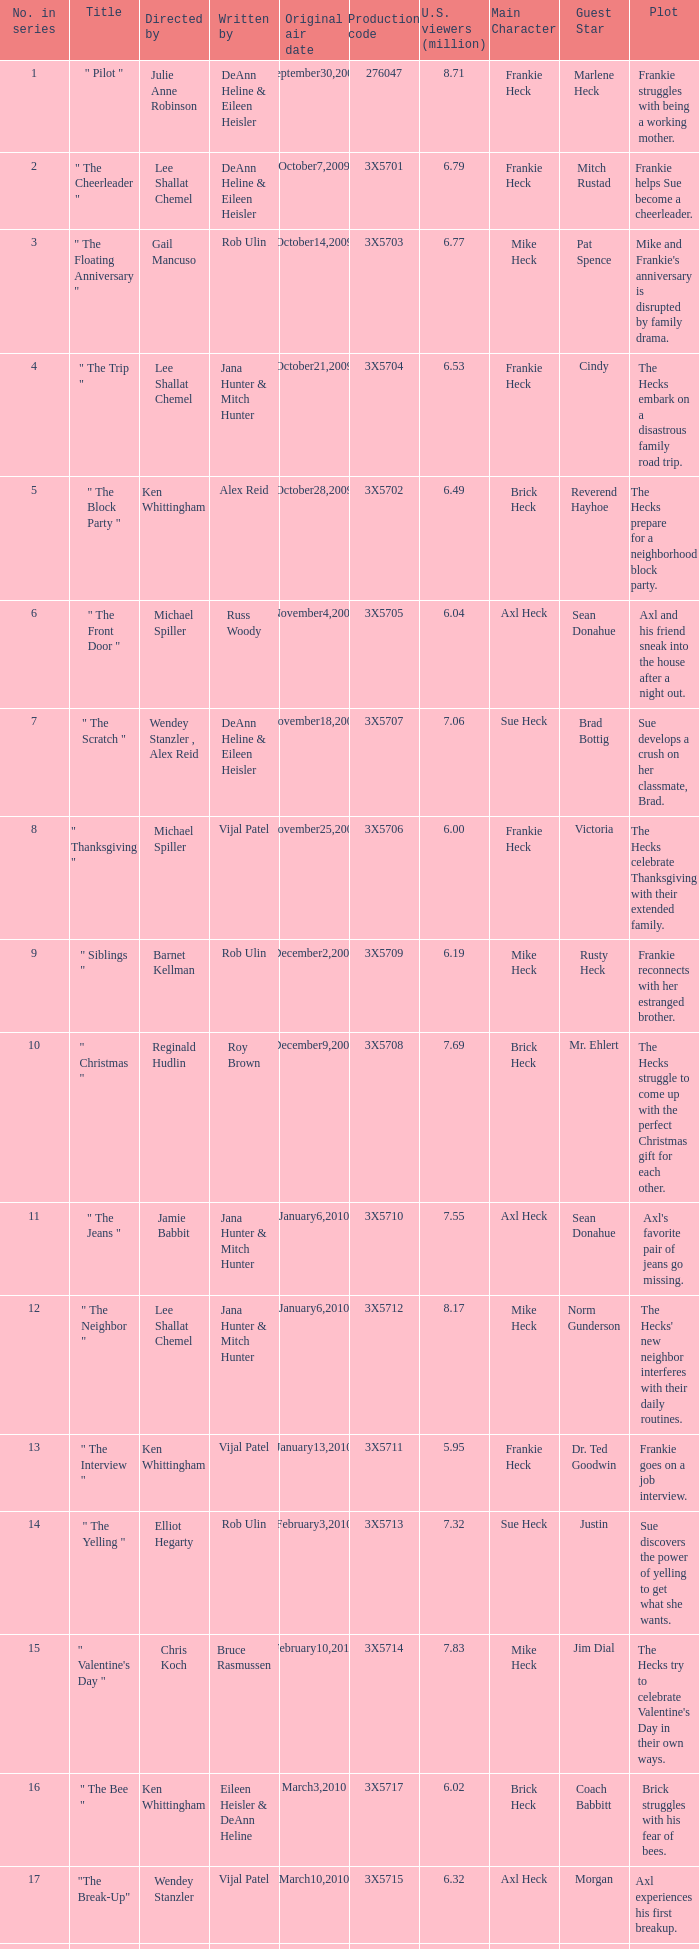What is the designation of the episode under alex reid's direction? "The Final Four". 